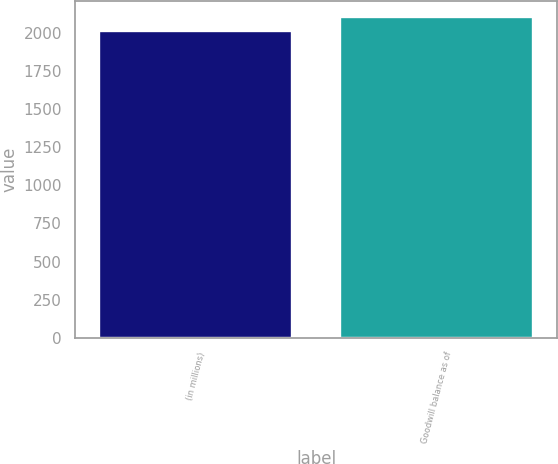Convert chart. <chart><loc_0><loc_0><loc_500><loc_500><bar_chart><fcel>(in millions)<fcel>Goodwill balance as of<nl><fcel>2017<fcel>2104.3<nl></chart> 